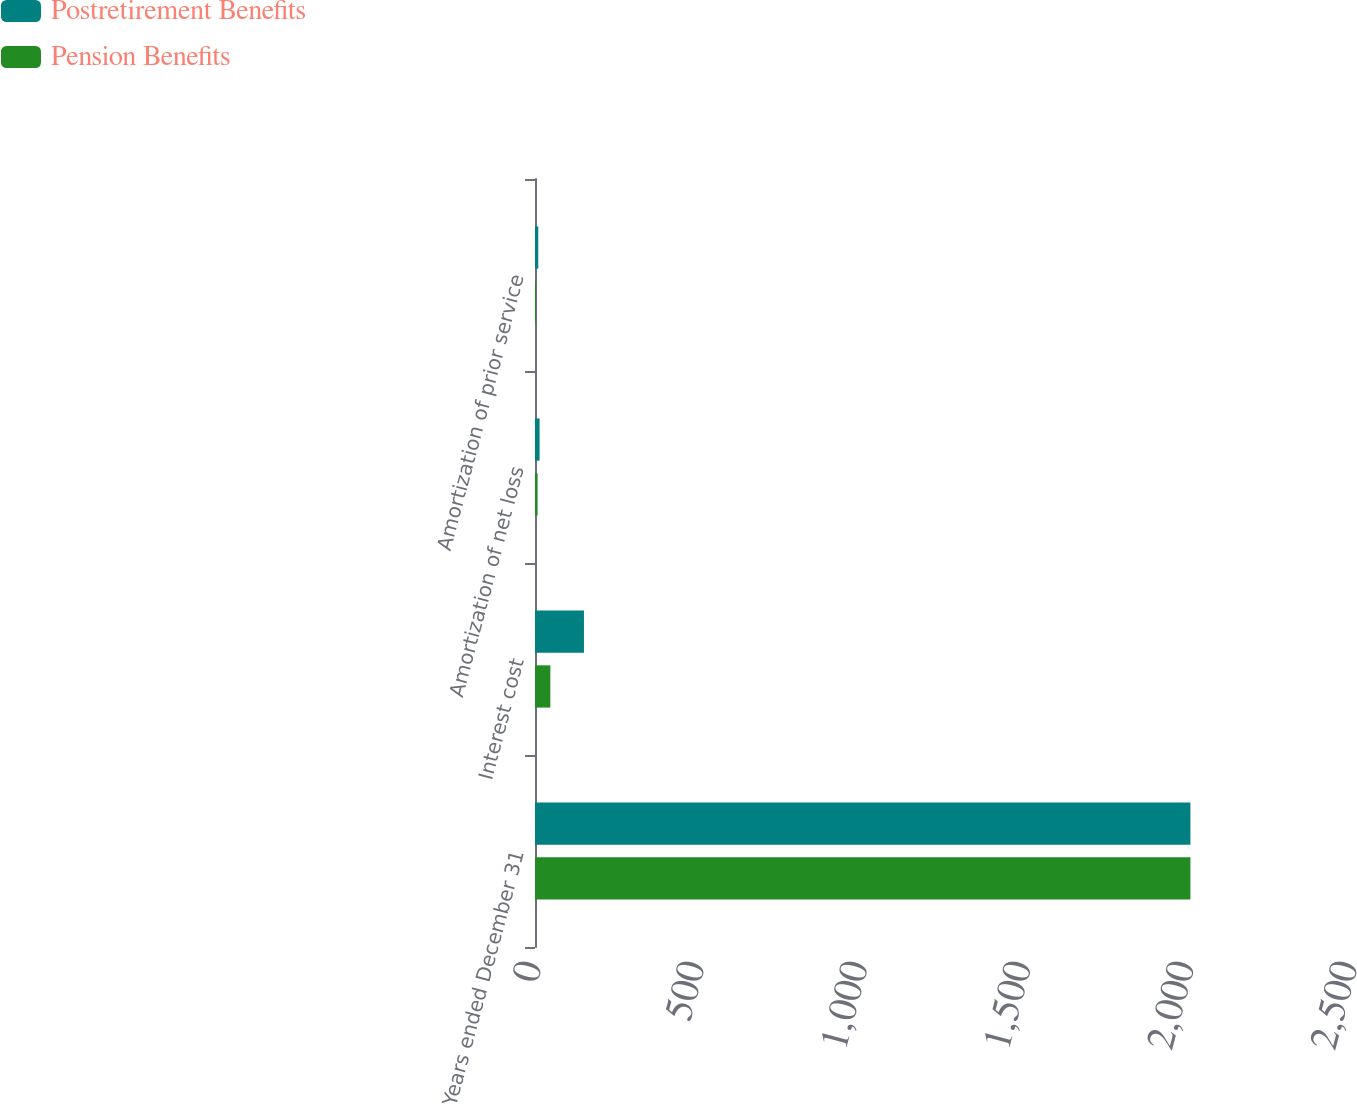<chart> <loc_0><loc_0><loc_500><loc_500><stacked_bar_chart><ecel><fcel>Years ended December 31<fcel>Interest cost<fcel>Amortization of net loss<fcel>Amortization of prior service<nl><fcel>Postretirement Benefits<fcel>2008<fcel>150<fcel>14<fcel>10<nl><fcel>Pension Benefits<fcel>2008<fcel>47<fcel>8<fcel>3<nl></chart> 